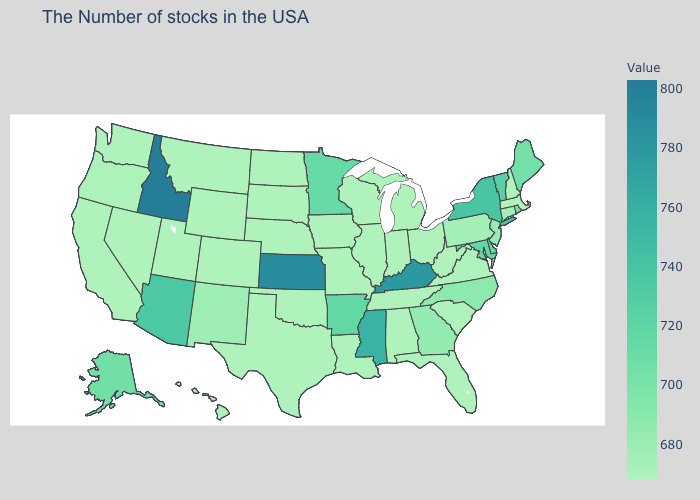Which states have the lowest value in the Northeast?
Concise answer only. Massachusetts, New Hampshire. Which states have the highest value in the USA?
Give a very brief answer. Idaho. Which states have the highest value in the USA?
Answer briefly. Idaho. 